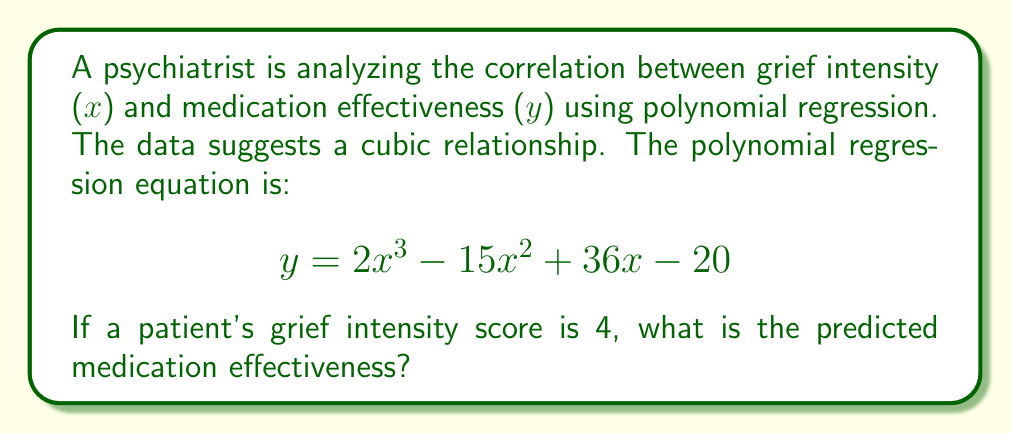Provide a solution to this math problem. To solve this problem, we need to substitute x = 4 into the given polynomial equation:

$$ y = 2x^3 - 15x^2 + 36x - 20 $$

Step 1: Substitute x = 4
$$ y = 2(4^3) - 15(4^2) + 36(4) - 20 $$

Step 2: Calculate the exponents
$$ y = 2(64) - 15(16) + 36(4) - 20 $$

Step 3: Multiply
$$ y = 128 - 240 + 144 - 20 $$

Step 4: Add and subtract from left to right
$$ y = -112 + 144 - 20 $$
$$ y = 32 - 20 $$
$$ y = 12 $$

Therefore, the predicted medication effectiveness for a patient with a grief intensity score of 4 is 12.
Answer: 12 